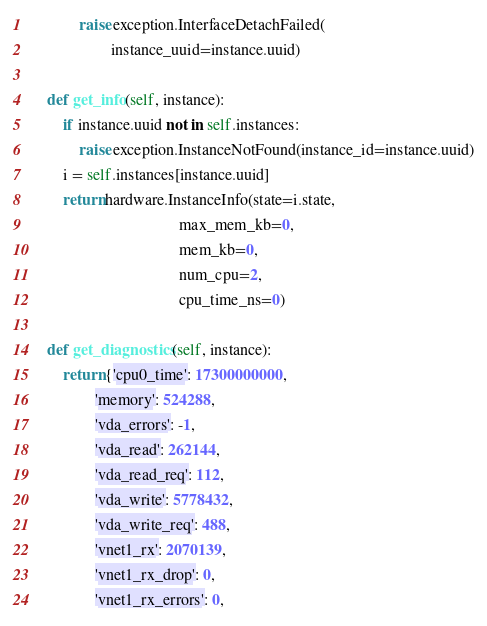Convert code to text. <code><loc_0><loc_0><loc_500><loc_500><_Python_>            raise exception.InterfaceDetachFailed(
                    instance_uuid=instance.uuid)

    def get_info(self, instance):
        if instance.uuid not in self.instances:
            raise exception.InstanceNotFound(instance_id=instance.uuid)
        i = self.instances[instance.uuid]
        return hardware.InstanceInfo(state=i.state,
                                     max_mem_kb=0,
                                     mem_kb=0,
                                     num_cpu=2,
                                     cpu_time_ns=0)

    def get_diagnostics(self, instance):
        return {'cpu0_time': 17300000000,
                'memory': 524288,
                'vda_errors': -1,
                'vda_read': 262144,
                'vda_read_req': 112,
                'vda_write': 5778432,
                'vda_write_req': 488,
                'vnet1_rx': 2070139,
                'vnet1_rx_drop': 0,
                'vnet1_rx_errors': 0,</code> 